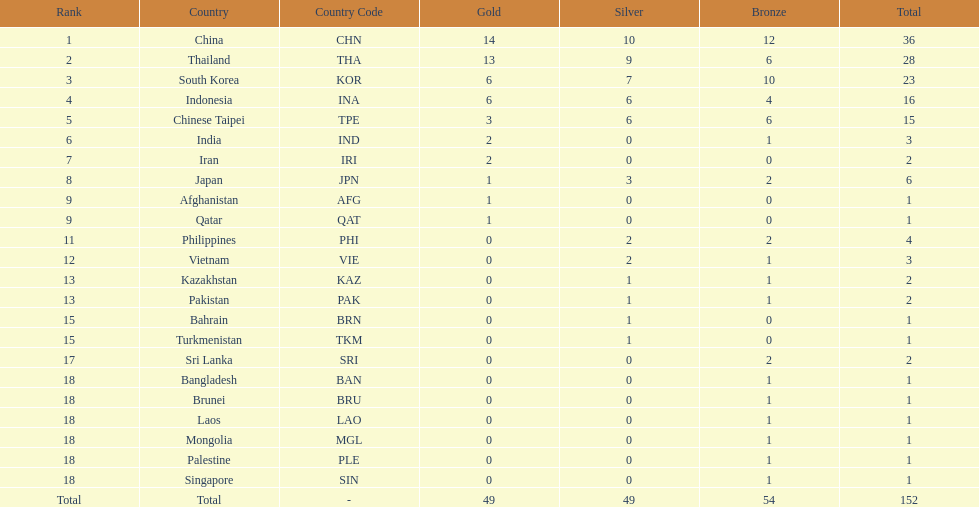How many total gold medal have been given? 49. 